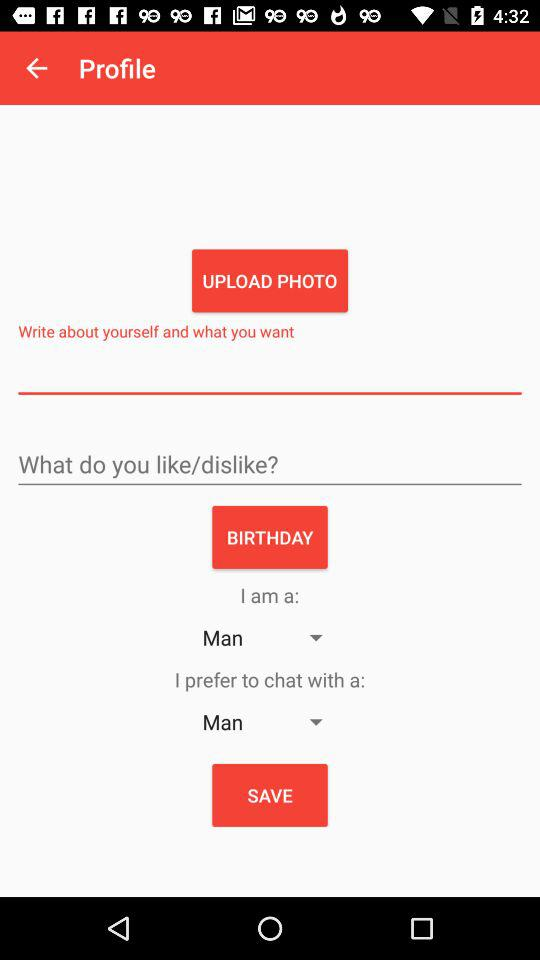Which option is selected in "I prefer to chat with a"? The selected option in "I prefer to chat with a" is "Man". 